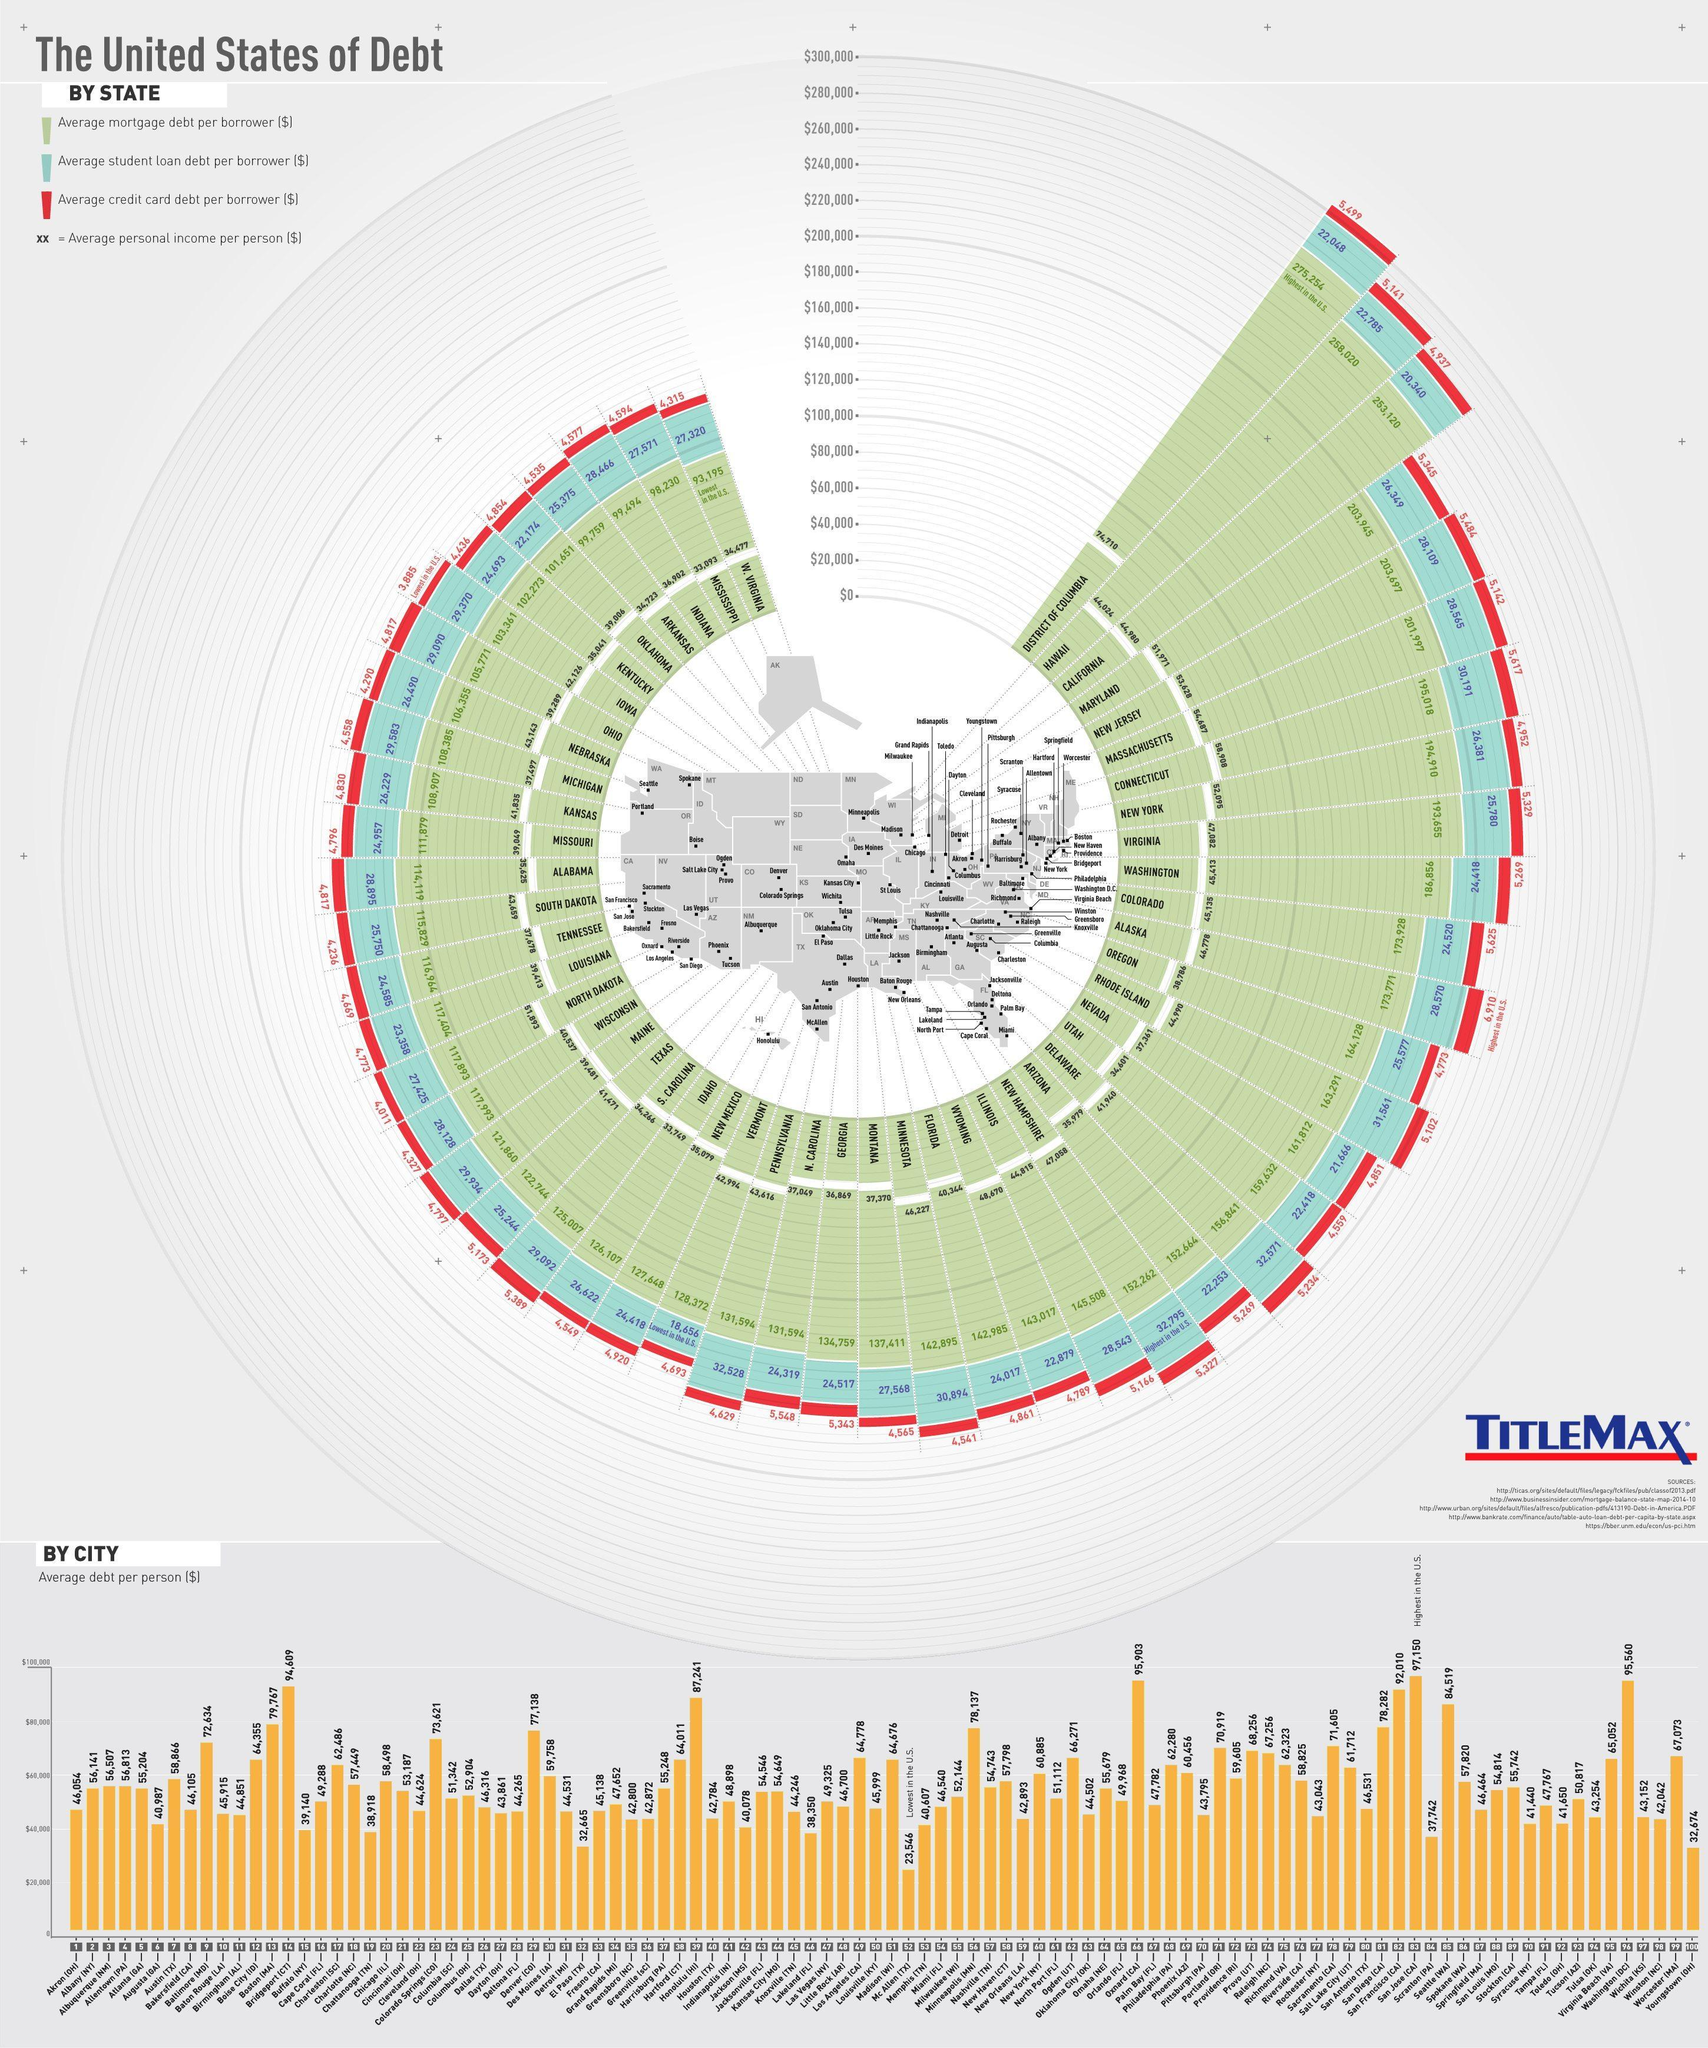what is the average student loan debt per borrower in Florida
Answer the question with a short phrase. 24,017 what is the average student loan debt per borrower in Indiana 28,466 which city has the lowest average debt per person Mc Allen (TX) what is the average credit card debt per borrower in Maine 4,797 what is the average credit card debt per borrower in New Jersey 5,484 what is the average mortgage debt per borrower in Texas 122,744 what is the average mortgage debt per borrower in Iowa 103,361 what is the average debt per person in Chicago 58,498 